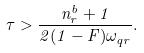Convert formula to latex. <formula><loc_0><loc_0><loc_500><loc_500>\tau > \frac { n _ { r } ^ { b } + 1 } { 2 ( 1 - F ) \omega _ { q r } } .</formula> 